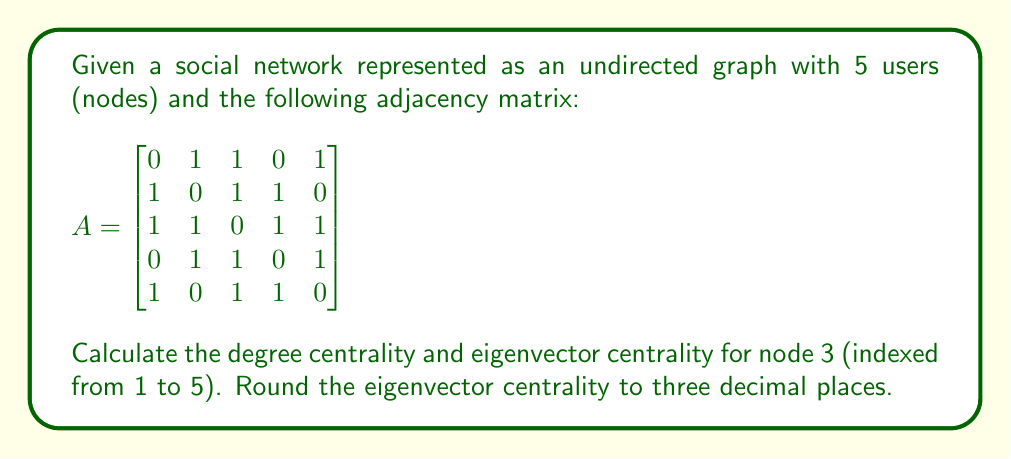Can you solve this math problem? To solve this problem, we'll calculate both the degree centrality and eigenvector centrality for node 3.

1. Degree Centrality:
The degree centrality is the number of connections a node has, divided by the maximum possible connections.

For node 3:
- Number of connections: 4 (sum of row 3 in the adjacency matrix)
- Maximum possible connections: 4 (n - 1, where n is the total number of nodes)

Degree centrality = $\frac{4}{4} = 1$

2. Eigenvector Centrality:
To calculate eigenvector centrality, we need to find the eigenvector corresponding to the largest eigenvalue of the adjacency matrix.

First, let's calculate the eigenvalues:
$$\det(A - \lambda I) = 0$$

Solving this equation gives us the following eigenvalues:
$\lambda_1 \approx 2.7364$, $\lambda_2 \approx 0.7364$, $\lambda_3 = 0$, $\lambda_4 = -1$, $\lambda_5 = -2$

The largest eigenvalue is $\lambda_1 \approx 2.7364$.

Now, we need to find the eigenvector corresponding to $\lambda_1$. Solving $(A - \lambda_1 I)x = 0$, we get the following eigenvector (normalized):

$$x \approx \begin{bmatrix}
0.4472 \\
0.4472 \\
0.5477 \\
0.4472 \\
0.4472
\end{bmatrix}$$

The eigenvector centrality for node 3 is the third component of this eigenvector: 0.5477

Rounding to three decimal places: 0.548
Answer: Degree centrality: 1, Eigenvector centrality: 0.548 